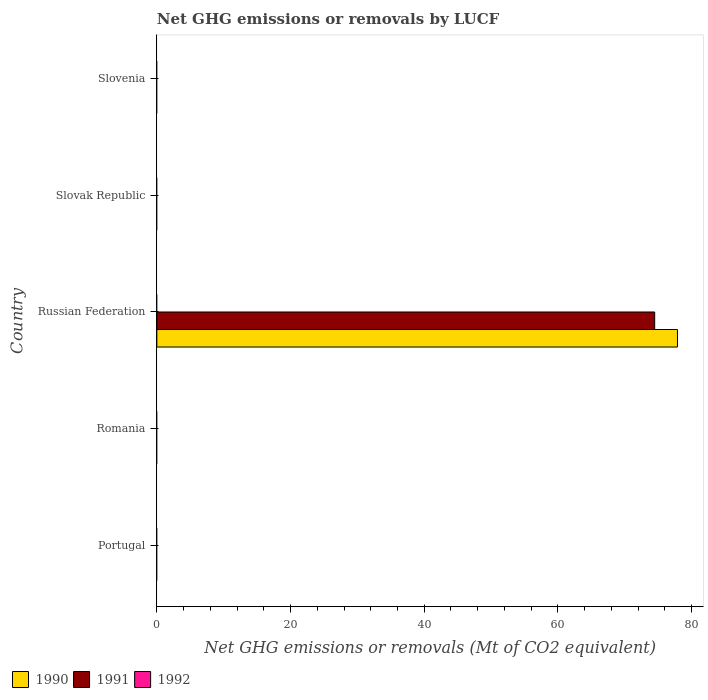How many different coloured bars are there?
Your answer should be very brief. 2. How many bars are there on the 3rd tick from the top?
Offer a terse response. 2. How many bars are there on the 1st tick from the bottom?
Give a very brief answer. 0. In how many cases, is the number of bars for a given country not equal to the number of legend labels?
Provide a short and direct response. 5. What is the net GHG emissions or removals by LUCF in 1991 in Russian Federation?
Keep it short and to the point. 74.48. Across all countries, what is the maximum net GHG emissions or removals by LUCF in 1990?
Provide a succinct answer. 77.88. Across all countries, what is the minimum net GHG emissions or removals by LUCF in 1991?
Keep it short and to the point. 0. In which country was the net GHG emissions or removals by LUCF in 1991 maximum?
Provide a short and direct response. Russian Federation. What is the total net GHG emissions or removals by LUCF in 1990 in the graph?
Give a very brief answer. 77.88. In how many countries, is the net GHG emissions or removals by LUCF in 1990 greater than 4 Mt?
Give a very brief answer. 1. What is the difference between the highest and the lowest net GHG emissions or removals by LUCF in 1991?
Your response must be concise. 74.48. In how many countries, is the net GHG emissions or removals by LUCF in 1990 greater than the average net GHG emissions or removals by LUCF in 1990 taken over all countries?
Your answer should be compact. 1. Is it the case that in every country, the sum of the net GHG emissions or removals by LUCF in 1992 and net GHG emissions or removals by LUCF in 1990 is greater than the net GHG emissions or removals by LUCF in 1991?
Offer a very short reply. No. How many bars are there?
Offer a very short reply. 2. Are all the bars in the graph horizontal?
Ensure brevity in your answer.  Yes. How many countries are there in the graph?
Make the answer very short. 5. Does the graph contain any zero values?
Provide a succinct answer. Yes. How many legend labels are there?
Ensure brevity in your answer.  3. How are the legend labels stacked?
Your response must be concise. Horizontal. What is the title of the graph?
Your answer should be very brief. Net GHG emissions or removals by LUCF. Does "1995" appear as one of the legend labels in the graph?
Ensure brevity in your answer.  No. What is the label or title of the X-axis?
Your answer should be compact. Net GHG emissions or removals (Mt of CO2 equivalent). What is the Net GHG emissions or removals (Mt of CO2 equivalent) of 1991 in Portugal?
Give a very brief answer. 0. What is the Net GHG emissions or removals (Mt of CO2 equivalent) in 1990 in Romania?
Make the answer very short. 0. What is the Net GHG emissions or removals (Mt of CO2 equivalent) in 1992 in Romania?
Provide a short and direct response. 0. What is the Net GHG emissions or removals (Mt of CO2 equivalent) of 1990 in Russian Federation?
Offer a terse response. 77.88. What is the Net GHG emissions or removals (Mt of CO2 equivalent) in 1991 in Russian Federation?
Provide a short and direct response. 74.48. What is the Net GHG emissions or removals (Mt of CO2 equivalent) in 1992 in Russian Federation?
Your response must be concise. 0. What is the Net GHG emissions or removals (Mt of CO2 equivalent) of 1990 in Slovak Republic?
Provide a succinct answer. 0. What is the Net GHG emissions or removals (Mt of CO2 equivalent) of 1991 in Slovak Republic?
Keep it short and to the point. 0. What is the Net GHG emissions or removals (Mt of CO2 equivalent) of 1991 in Slovenia?
Keep it short and to the point. 0. Across all countries, what is the maximum Net GHG emissions or removals (Mt of CO2 equivalent) of 1990?
Your answer should be very brief. 77.88. Across all countries, what is the maximum Net GHG emissions or removals (Mt of CO2 equivalent) of 1991?
Your response must be concise. 74.48. Across all countries, what is the minimum Net GHG emissions or removals (Mt of CO2 equivalent) in 1990?
Your response must be concise. 0. Across all countries, what is the minimum Net GHG emissions or removals (Mt of CO2 equivalent) of 1991?
Ensure brevity in your answer.  0. What is the total Net GHG emissions or removals (Mt of CO2 equivalent) in 1990 in the graph?
Provide a short and direct response. 77.89. What is the total Net GHG emissions or removals (Mt of CO2 equivalent) in 1991 in the graph?
Provide a succinct answer. 74.48. What is the total Net GHG emissions or removals (Mt of CO2 equivalent) in 1992 in the graph?
Offer a very short reply. 0. What is the average Net GHG emissions or removals (Mt of CO2 equivalent) of 1990 per country?
Your answer should be very brief. 15.58. What is the average Net GHG emissions or removals (Mt of CO2 equivalent) of 1991 per country?
Provide a short and direct response. 14.9. What is the difference between the Net GHG emissions or removals (Mt of CO2 equivalent) of 1990 and Net GHG emissions or removals (Mt of CO2 equivalent) of 1991 in Russian Federation?
Ensure brevity in your answer.  3.41. What is the difference between the highest and the lowest Net GHG emissions or removals (Mt of CO2 equivalent) in 1990?
Provide a succinct answer. 77.89. What is the difference between the highest and the lowest Net GHG emissions or removals (Mt of CO2 equivalent) of 1991?
Your answer should be compact. 74.48. 